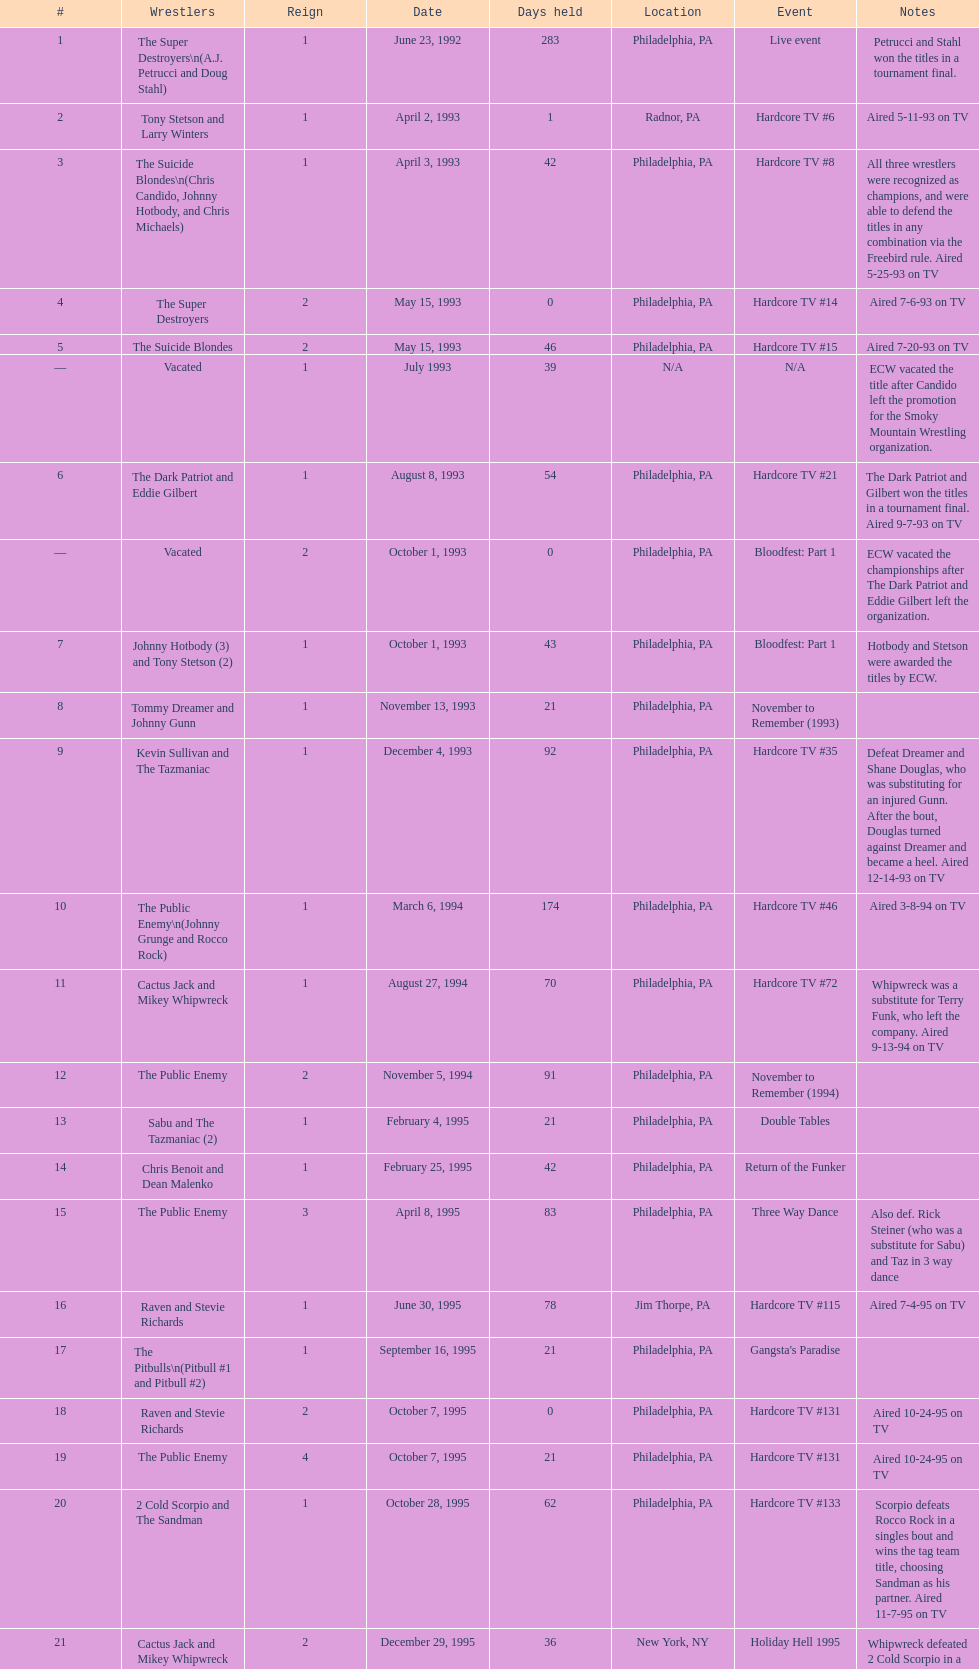Who held the title the most times, the super destroyers or the dudley boyz? The Dudley Boyz. 